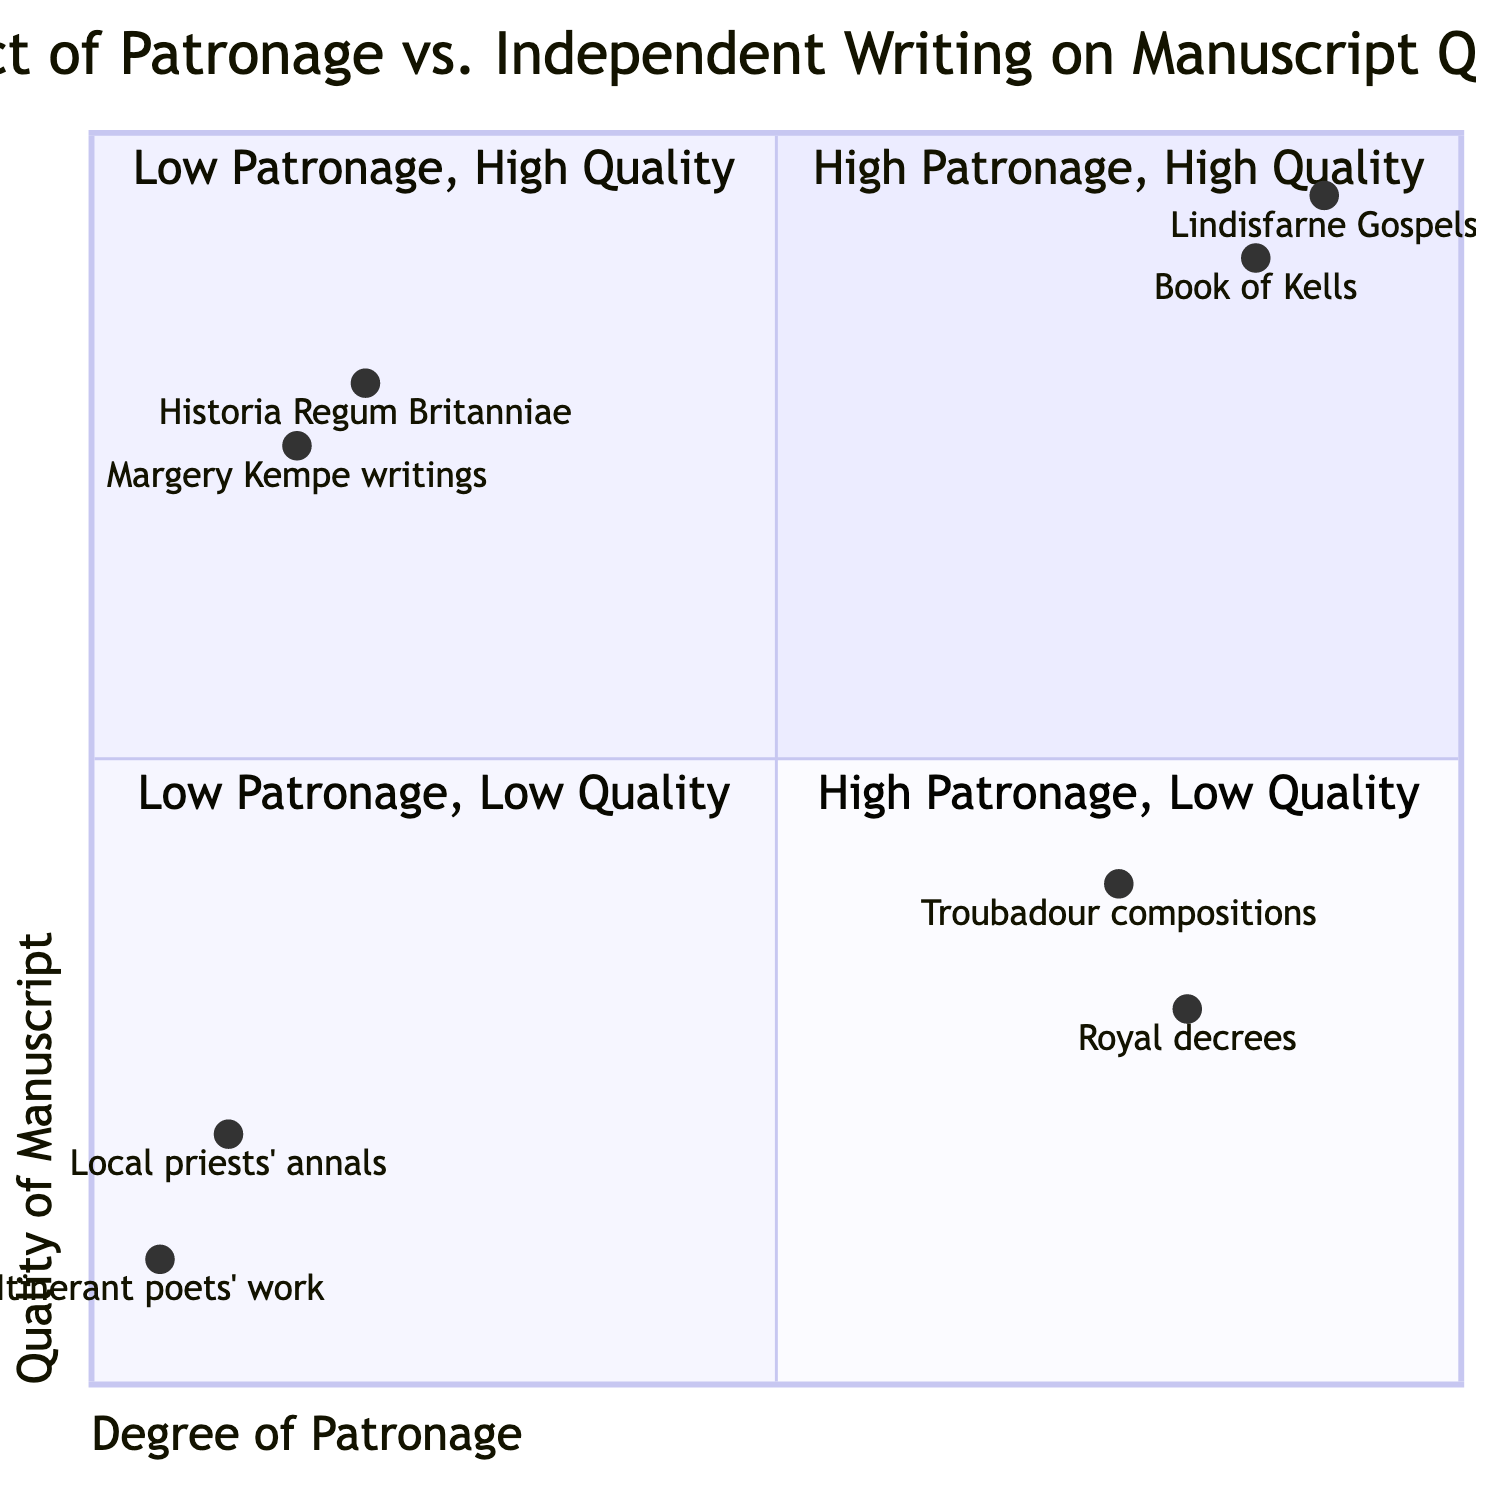What is the highest manuscript quality value in the chart? The highest quality value indicated in the chart is 0.95, corresponding to the Lindisfarne Gospels in the High Patronage/High Quality quadrant.
Answer: 0.95 Which manuscript belongs to the Low Patronage/High Quality quadrant? The writings of Margery Kempe and Geoffrey of Monmouth's Historia Regum Britanniae are the two manuscripts located in the Low Patronage/High Quality quadrant of the chart.
Answer: Margery Kempe writings What descriptors are associated with the High Patronage/Low Quality quadrant? This quadrant has descriptors such as "Prevalent pressure to adhere to patron's wishes influencing creativity" and "Luxury of materials overshadowed by lack of literary innovation."
Answer: Prevalent pressure to adhere to patron's wishes influencing creativity How many manuscripts are in the High Patronage/High Quality quadrant? There are two manuscripts in the High Patronage/High Quality quadrant, which are the Lindisfarne Gospels and the Book of Kells.
Answer: 2 What is the quality value of itinerant poets' work? The quality value of itinerant poets' work, which is located in the Low Patronage/Low Quality quadrant, is 0.1.
Answer: 0.1 Explain why certain royal decrees could represent Low Quality despite High Patronage. Royal decrees could represent Low Quality because, although they may have been produced with lavish materials due to patronage, the pressure to fulfill specific desires of the patron could lead to creativity being stifled, resulting in poor literary innovation despite the ornamental presentation.
Answer: Pressure to adhere to patron's wishes Which quadrant contains manuscripts produced quickly without refinement? The Low Patronage/Low Quality quadrant contains manuscripts produced quickly without refinement, as it is characterized by limited resources and lack of formal education or training.
Answer: Low Patronage/Low Quality What is the lowest quality value in the chart? The lowest quality value in the chart is 0.1, corresponding to itinerant poets' work in the Low Patronage/Low Quality quadrant.
Answer: 0.1 